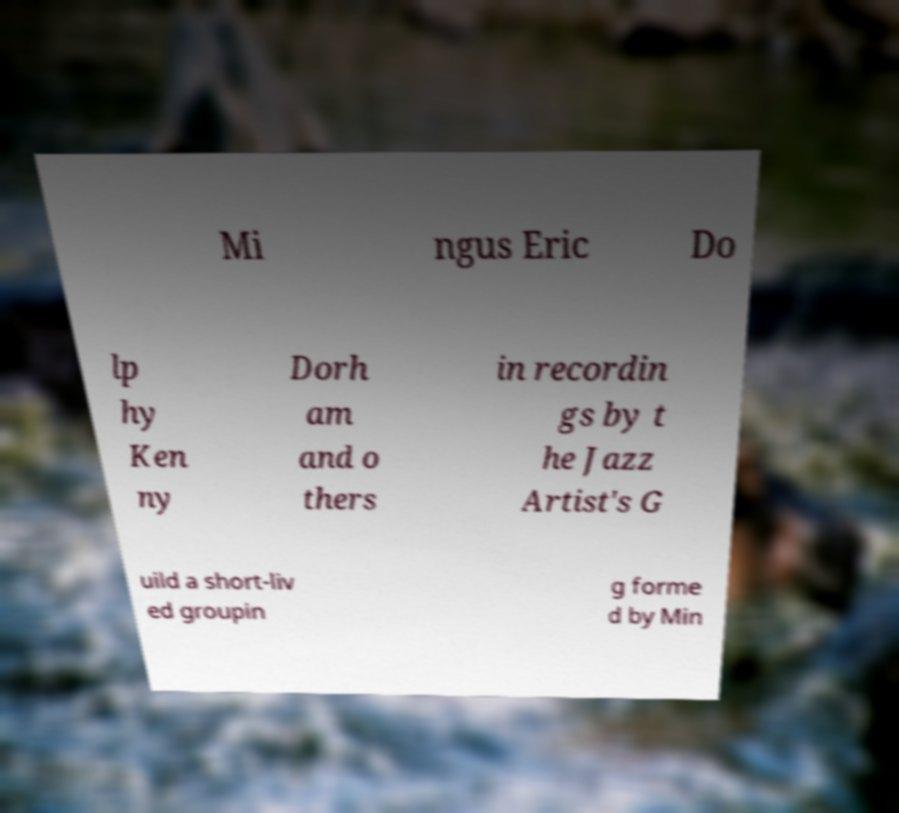Can you accurately transcribe the text from the provided image for me? Mi ngus Eric Do lp hy Ken ny Dorh am and o thers in recordin gs by t he Jazz Artist's G uild a short-liv ed groupin g forme d by Min 